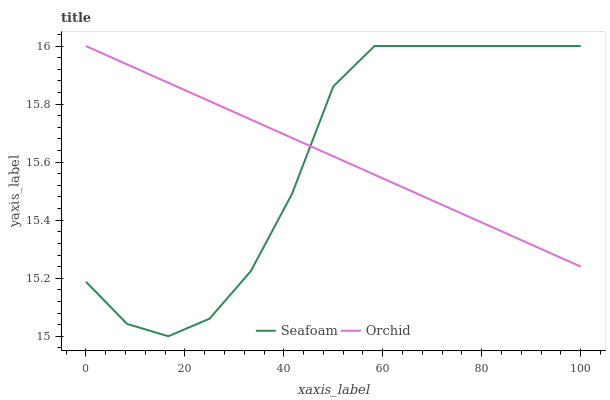Does Seafoam have the minimum area under the curve?
Answer yes or no. Yes. Does Orchid have the maximum area under the curve?
Answer yes or no. Yes. Does Orchid have the minimum area under the curve?
Answer yes or no. No. Is Orchid the smoothest?
Answer yes or no. Yes. Is Seafoam the roughest?
Answer yes or no. Yes. Is Orchid the roughest?
Answer yes or no. No. Does Orchid have the lowest value?
Answer yes or no. No. 